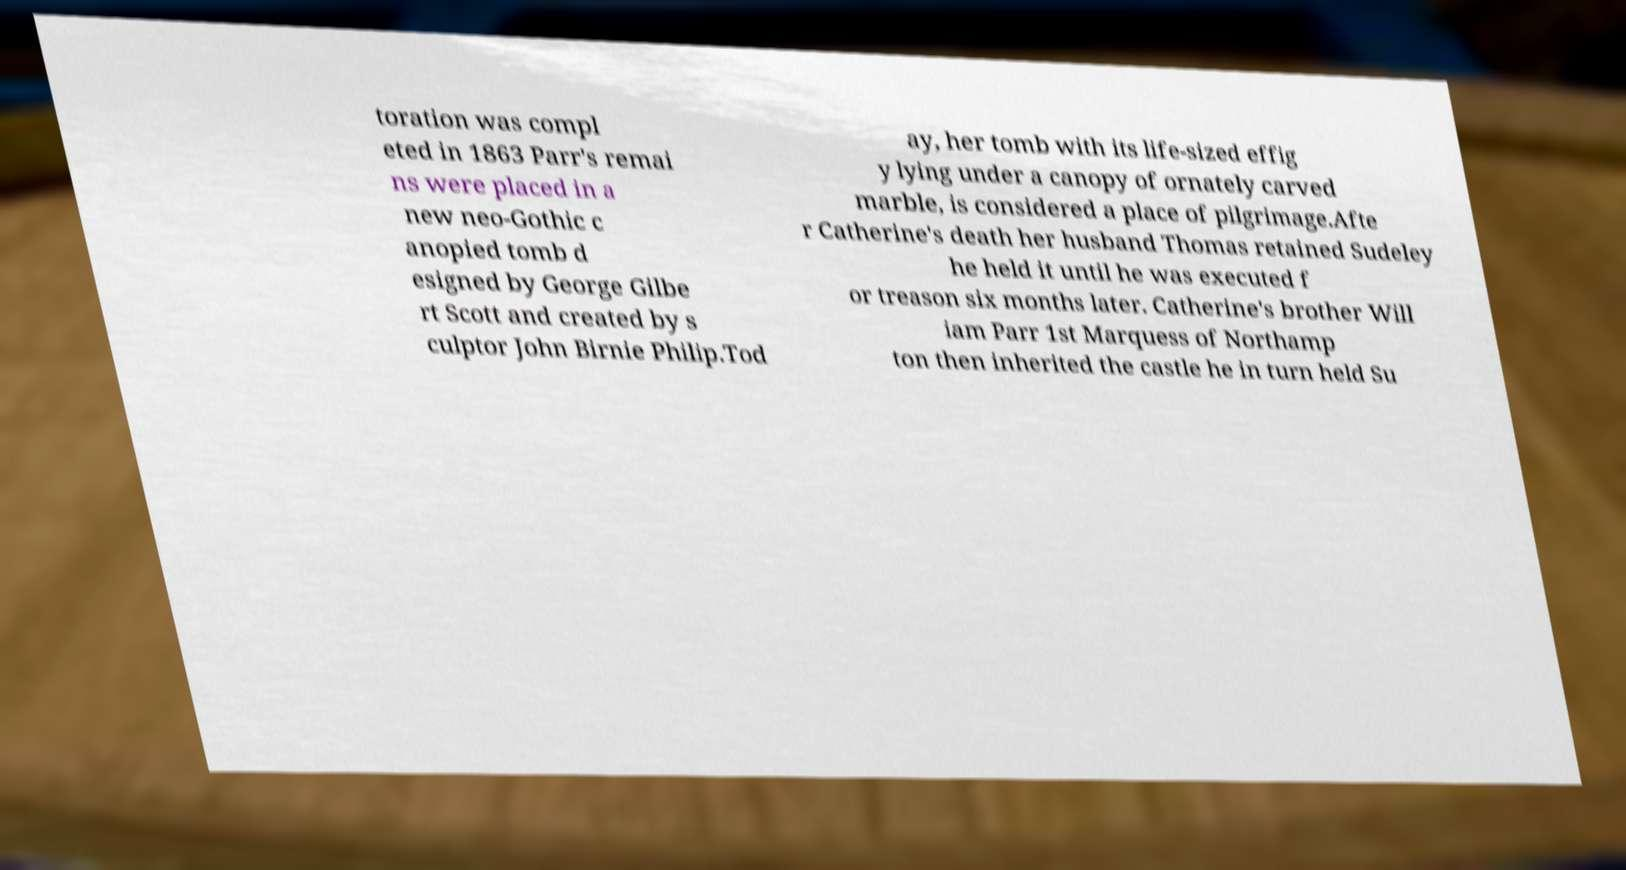Can you accurately transcribe the text from the provided image for me? toration was compl eted in 1863 Parr's remai ns were placed in a new neo-Gothic c anopied tomb d esigned by George Gilbe rt Scott and created by s culptor John Birnie Philip.Tod ay, her tomb with its life-sized effig y lying under a canopy of ornately carved marble, is considered a place of pilgrimage.Afte r Catherine's death her husband Thomas retained Sudeley he held it until he was executed f or treason six months later. Catherine's brother Will iam Parr 1st Marquess of Northamp ton then inherited the castle he in turn held Su 